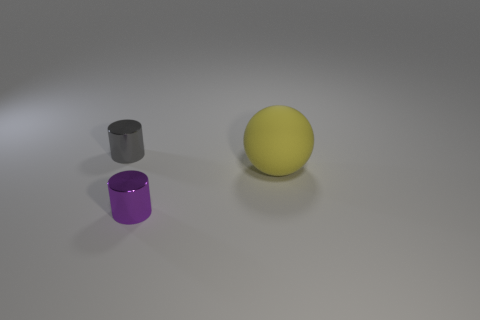Add 3 small purple cylinders. How many objects exist? 6 Subtract all cylinders. How many objects are left? 1 Subtract 0 blue spheres. How many objects are left? 3 Subtract all large blue objects. Subtract all shiny objects. How many objects are left? 1 Add 1 matte objects. How many matte objects are left? 2 Add 2 gray shiny cylinders. How many gray shiny cylinders exist? 3 